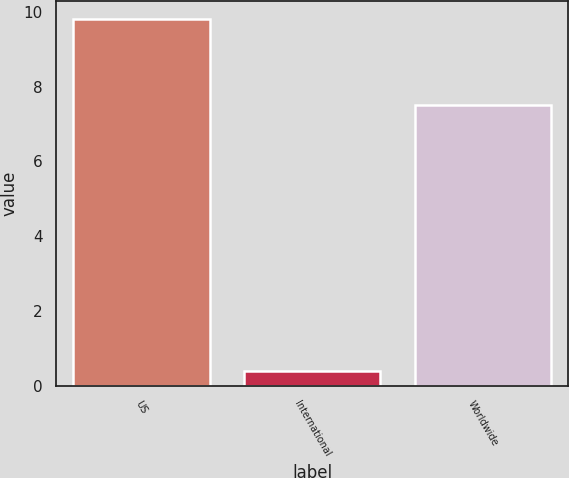<chart> <loc_0><loc_0><loc_500><loc_500><bar_chart><fcel>US<fcel>International<fcel>Worldwide<nl><fcel>9.8<fcel>0.4<fcel>7.5<nl></chart> 